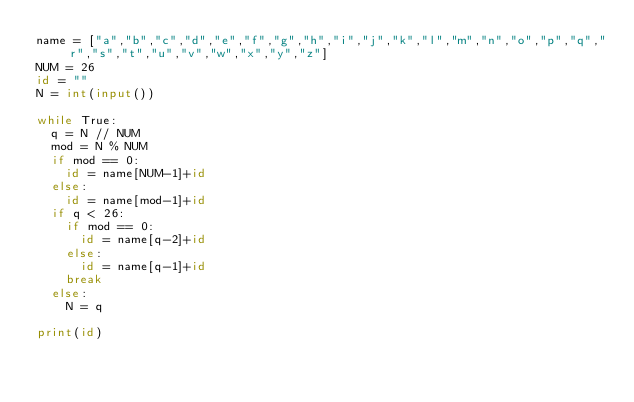Convert code to text. <code><loc_0><loc_0><loc_500><loc_500><_Python_>name = ["a","b","c","d","e","f","g","h","i","j","k","l","m","n","o","p","q","r","s","t","u","v","w","x","y","z"]
NUM = 26
id = ""
N = int(input())

while True:
  q = N // NUM
  mod = N % NUM
  if mod == 0:
    id = name[NUM-1]+id
  else:
    id = name[mod-1]+id
  if q < 26:
    if mod == 0:
      id = name[q-2]+id
    else:
      id = name[q-1]+id
    break
  else:
    N = q
    
print(id)</code> 